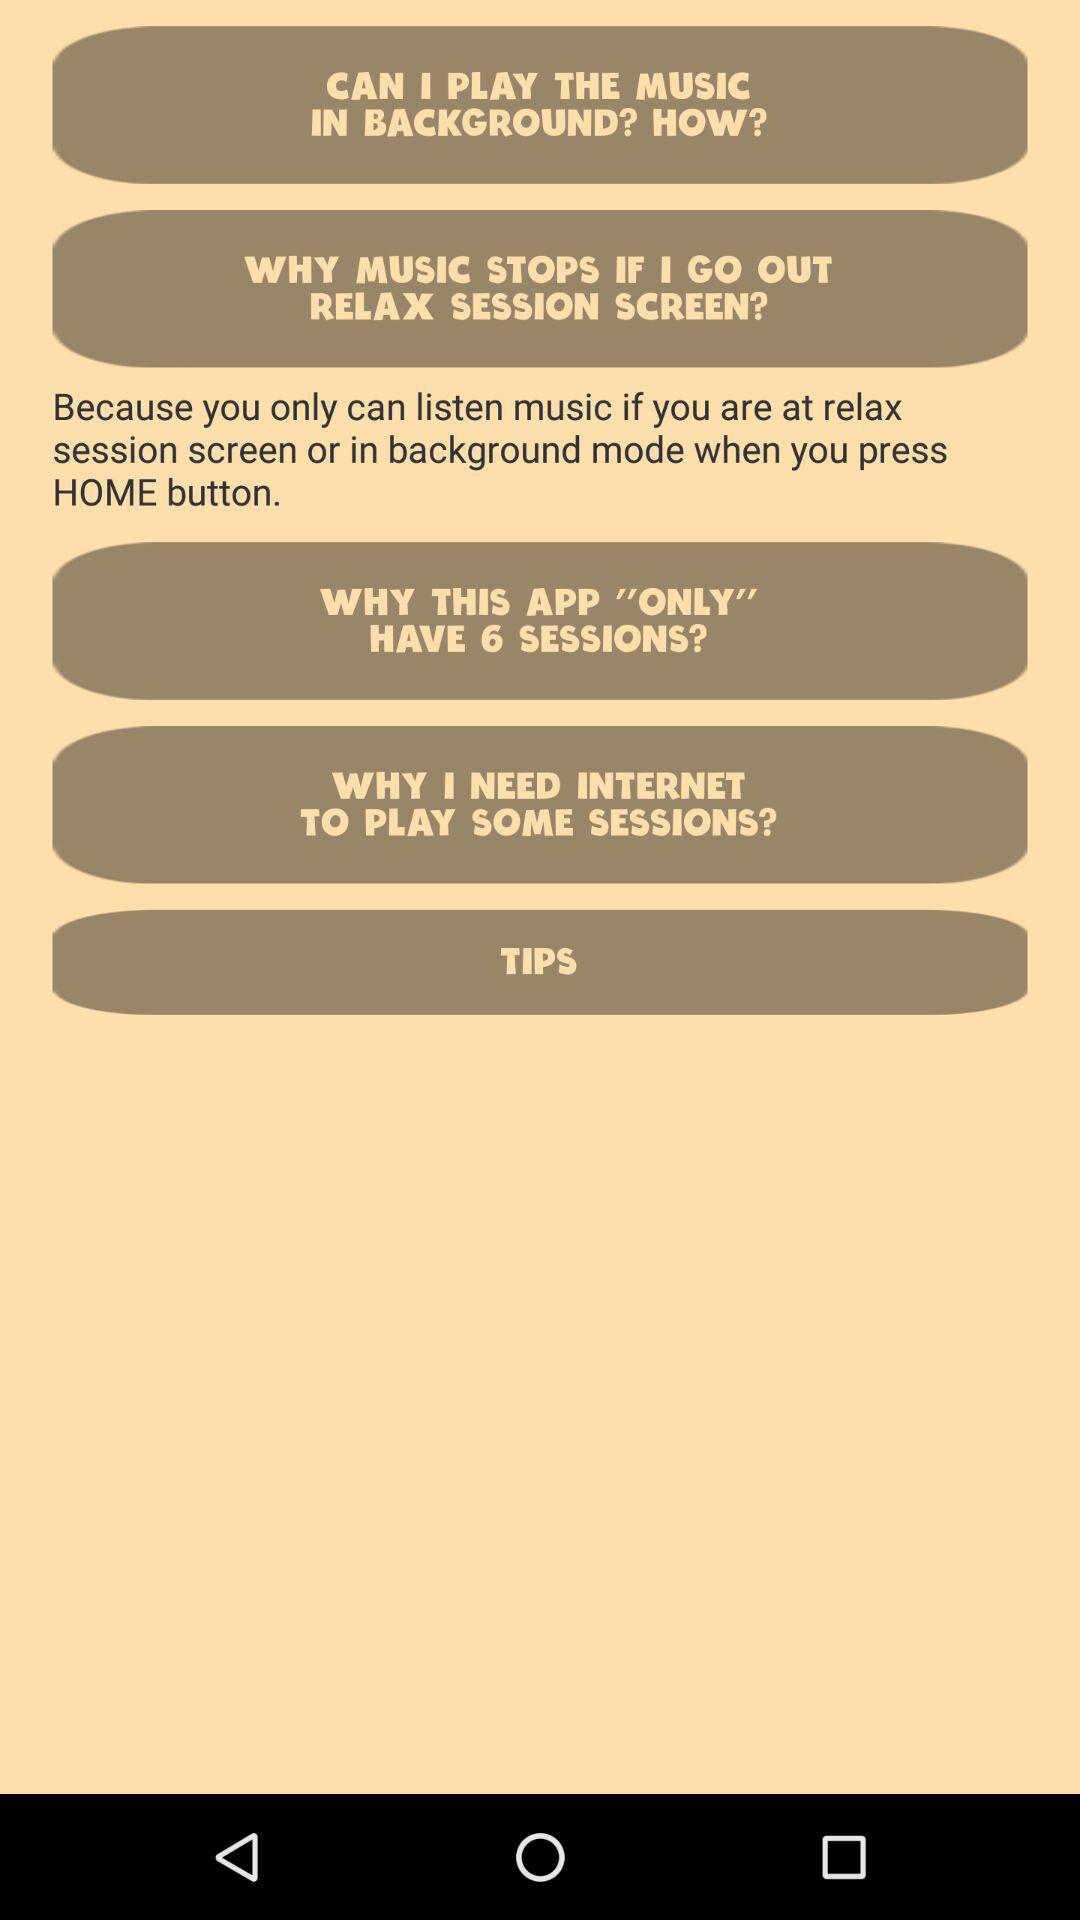How many sessions are there? There are 6 sessions. 